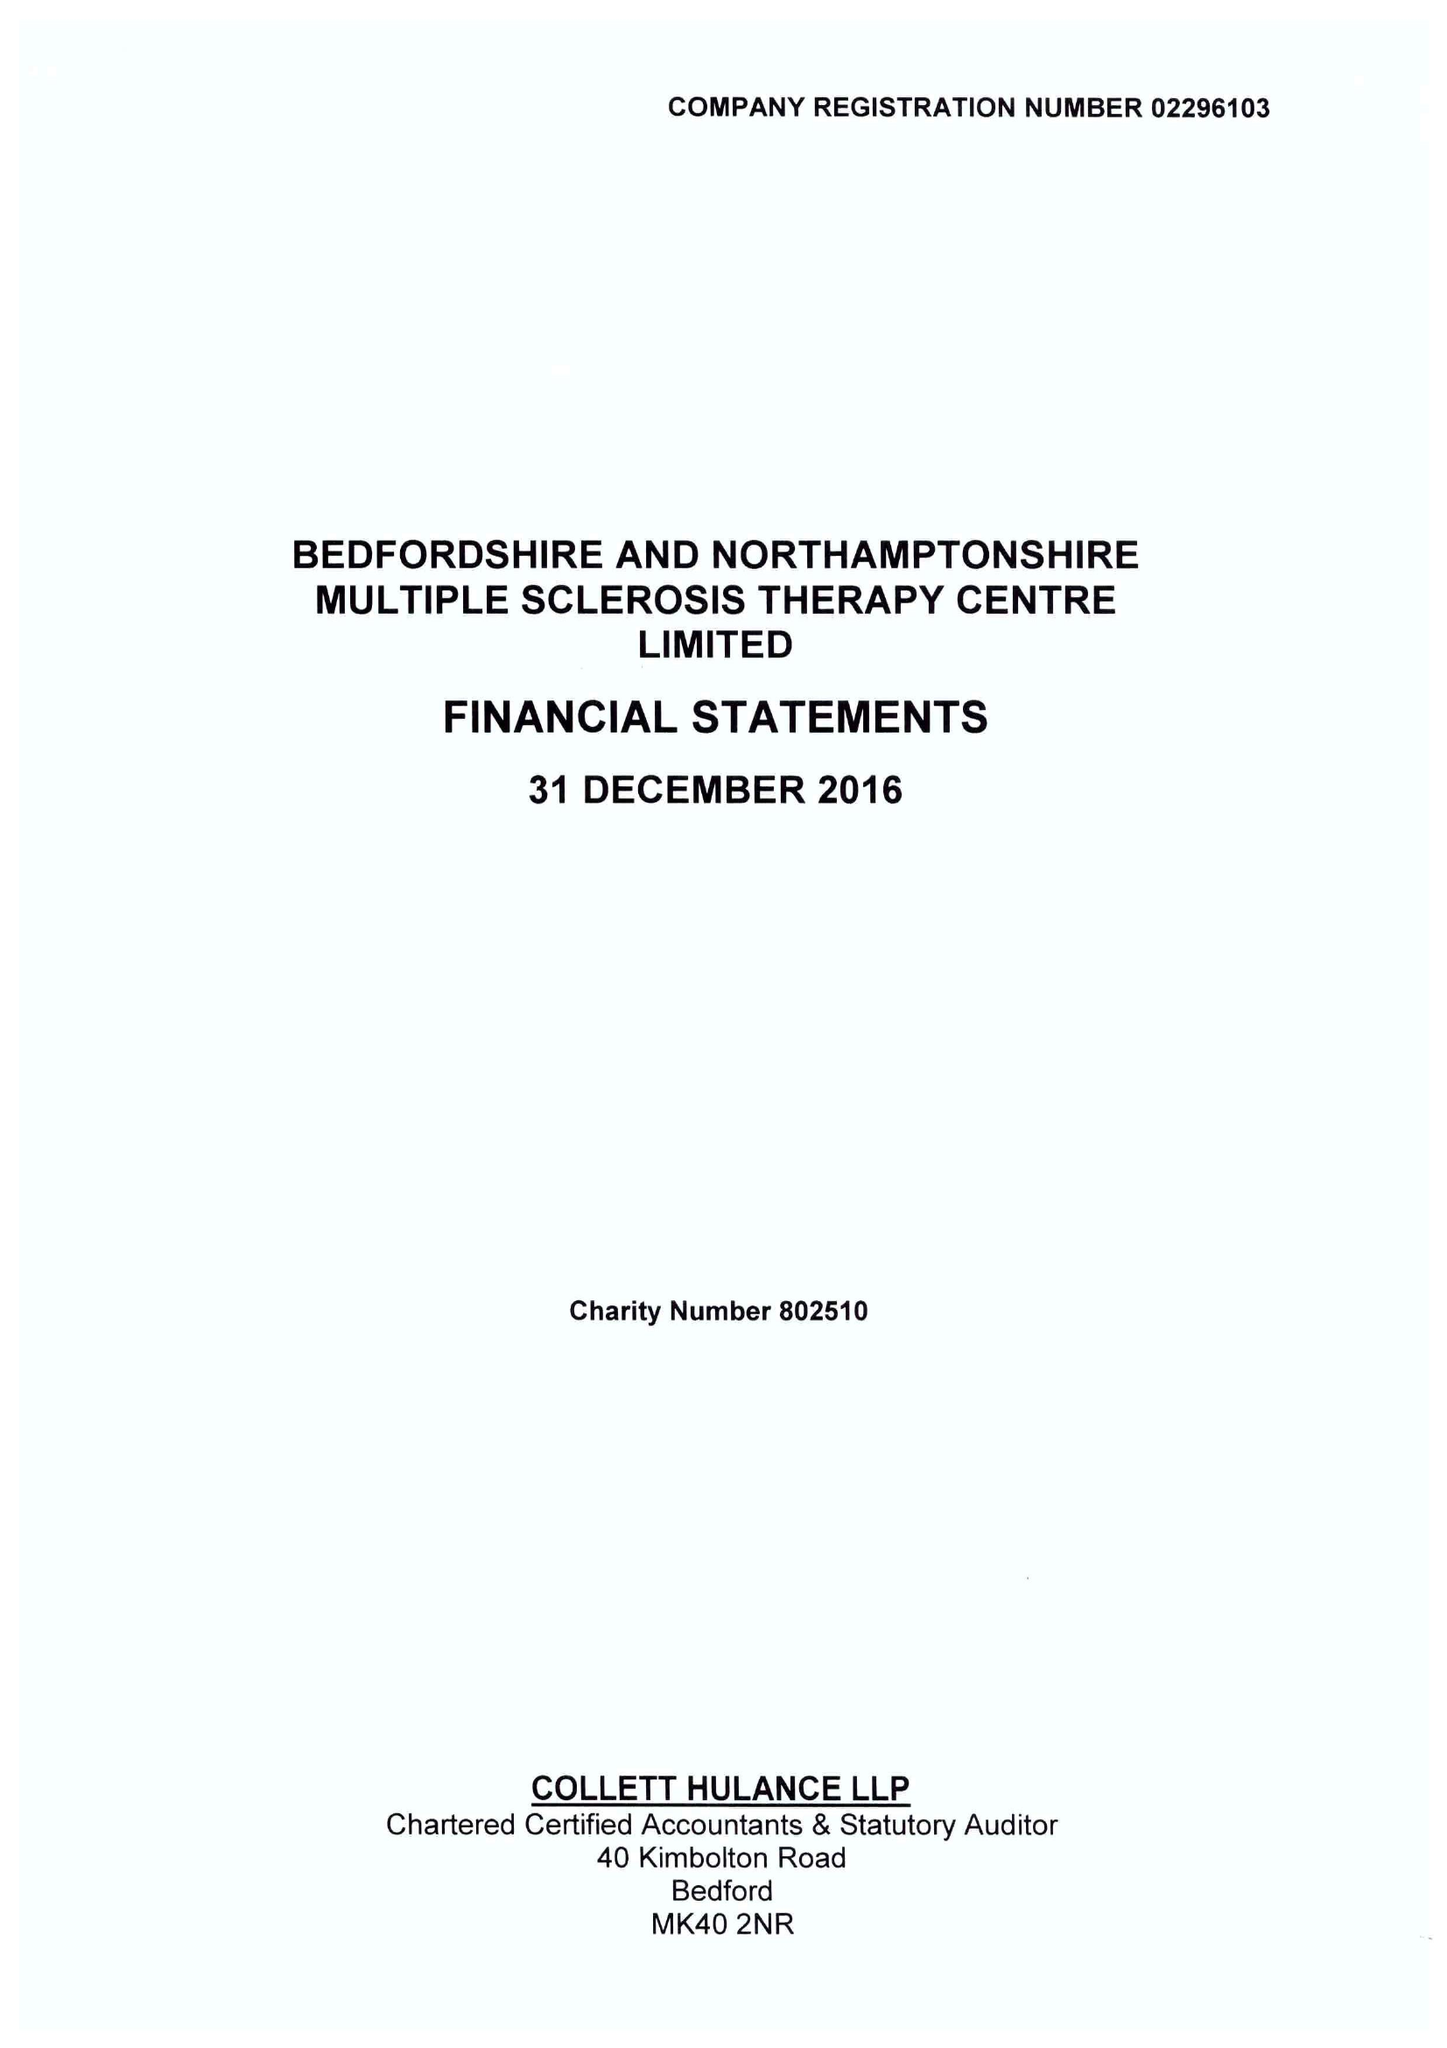What is the value for the income_annually_in_british_pounds?
Answer the question using a single word or phrase. 418971.00 